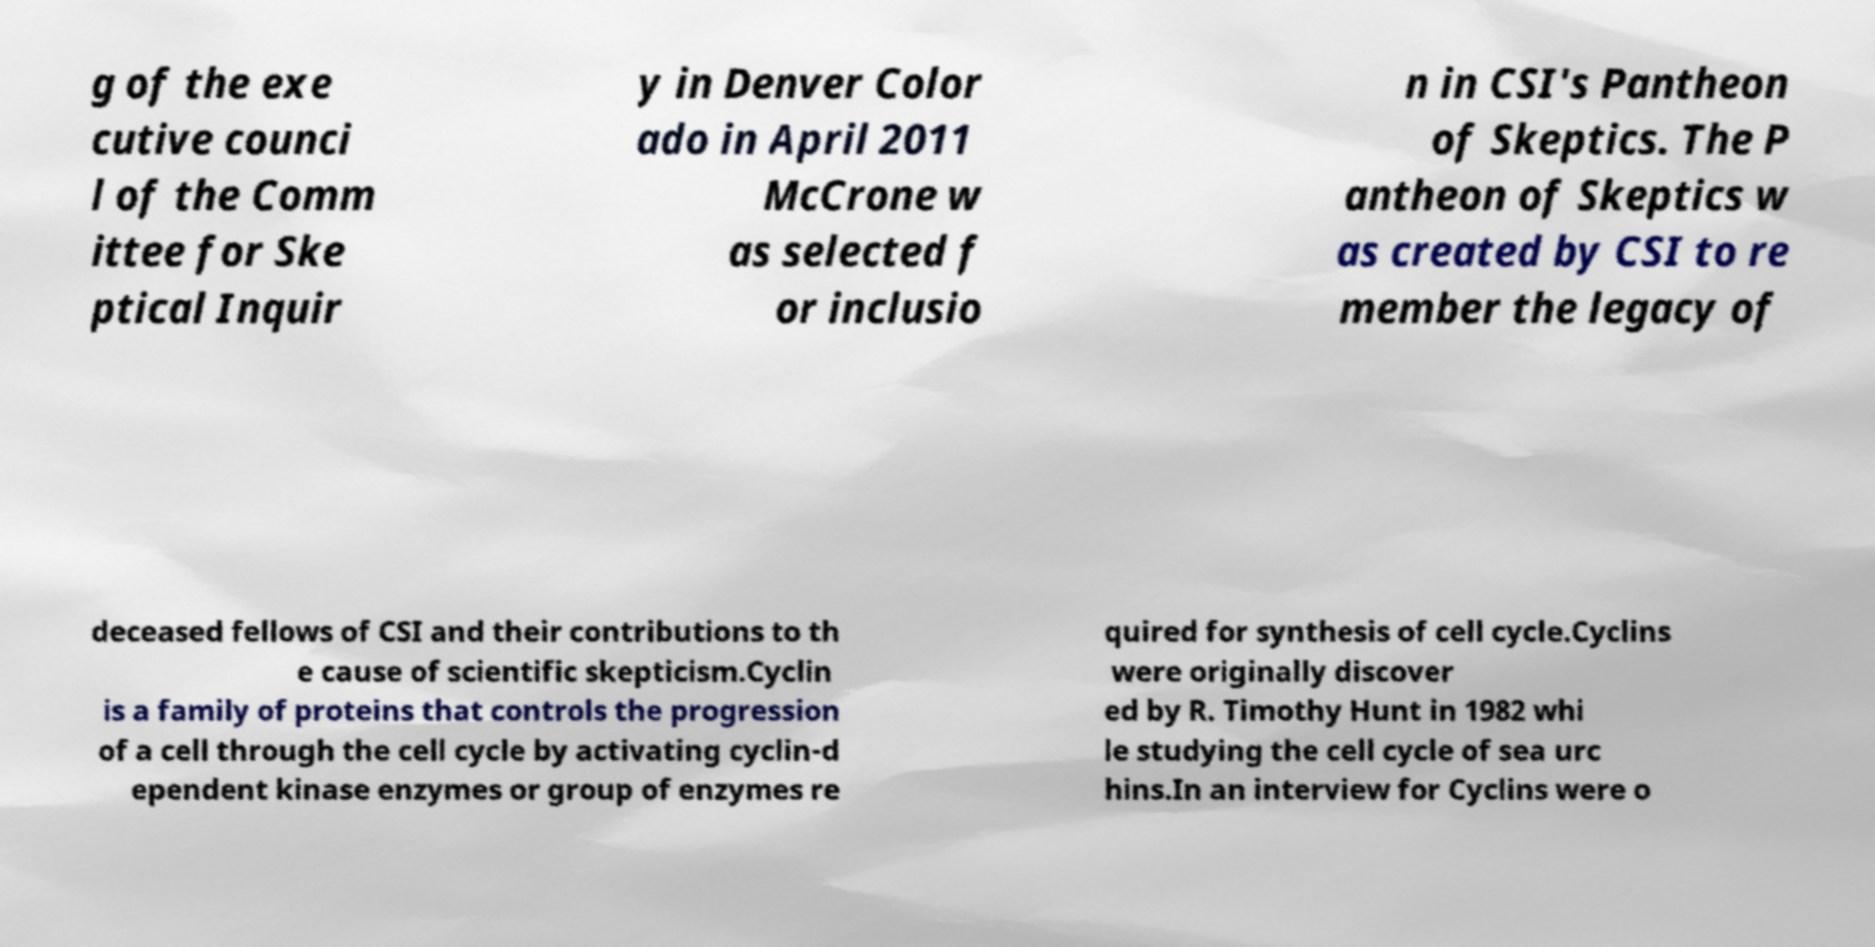For documentation purposes, I need the text within this image transcribed. Could you provide that? g of the exe cutive counci l of the Comm ittee for Ske ptical Inquir y in Denver Color ado in April 2011 McCrone w as selected f or inclusio n in CSI's Pantheon of Skeptics. The P antheon of Skeptics w as created by CSI to re member the legacy of deceased fellows of CSI and their contributions to th e cause of scientific skepticism.Cyclin is a family of proteins that controls the progression of a cell through the cell cycle by activating cyclin-d ependent kinase enzymes or group of enzymes re quired for synthesis of cell cycle.Cyclins were originally discover ed by R. Timothy Hunt in 1982 whi le studying the cell cycle of sea urc hins.In an interview for Cyclins were o 